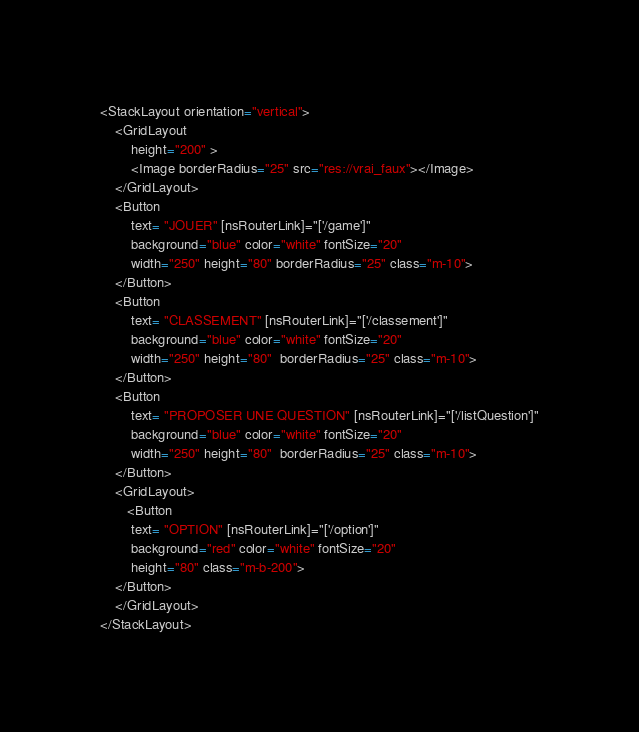<code> <loc_0><loc_0><loc_500><loc_500><_HTML_><StackLayout orientation="vertical">
    <GridLayout 
        height="200" >
        <Image borderRadius="25" src="res://vrai_faux"></Image>
    </GridLayout>
    <Button  
        text= "JOUER" [nsRouterLink]="['/game']"
        background="blue" color="white" fontSize="20"
        width="250" height="80" borderRadius="25" class="m-10">
    </Button>               
    <Button 
        text= "CLASSEMENT" [nsRouterLink]="['/classement']"
        background="blue" color="white" fontSize="20"
        width="250" height="80"  borderRadius="25" class="m-10">
    </Button>
    <Button 
        text= "PROPOSER UNE QUESTION" [nsRouterLink]="['/listQuestion']"
        background="blue" color="white" fontSize="20"
        width="250" height="80"  borderRadius="25" class="m-10">
    </Button>  
    <GridLayout>
       <Button 
        text= "OPTION" [nsRouterLink]="['/option']"
        background="red" color="white" fontSize="20"
        height="80" class="m-b-200">
    </Button>     
    </GridLayout> 
</StackLayout></code> 